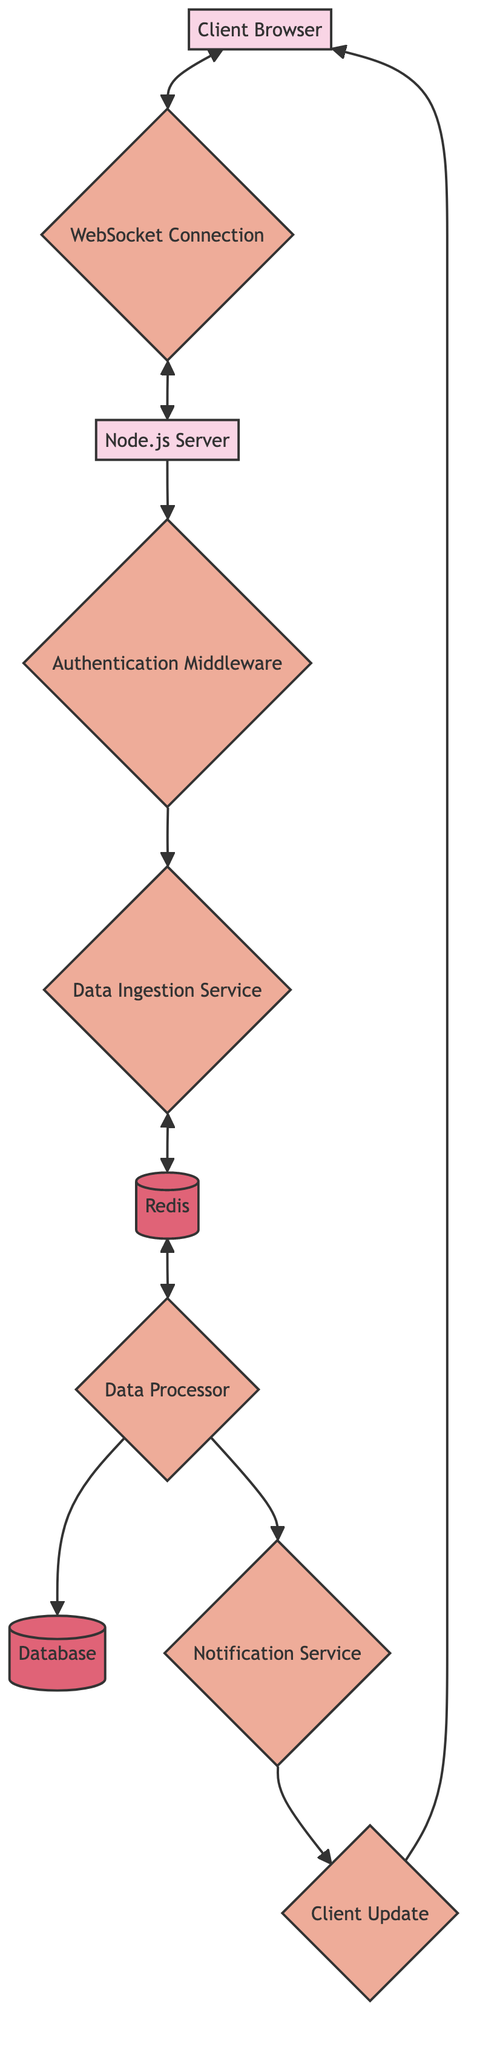What is the starting point of the workflow? The workflow starts with the "Client Browser" which initiates the data stream.
Answer: Client Browser How many entities are present in the workflow? There are three entities: Client Browser, Node.js Server, and Database.
Answer: Three What is the role of the "Authentication Middleware"? The "Authentication Middleware" ensures that the client is authorized to send and receive real-time data.
Answer: Authorization Which component is responsible for sending notifications to clients? The "Notification Service" is responsible for sending notifications or updates to clients after data processing.
Answer: Notification Service What type of connection is established between the Client Browser and the Node.js Server? A "WebSocket Connection" is established between the Client Browser and the Node.js Server.
Answer: WebSocket Connection What type of store is used as a message broker in the workflow? "Redis" is used as an in-memory data structure store for message brokering in the workflow.
Answer: Redis How does data flow from the Data Processor to the Database? The Data Processor processes data and then sends it directly to the Database for persistence.
Answer: Directly Which process follows the Data Ingestion Service? The "Data Processor" follows the Data Ingestion Service and applies business logic to the ingested data.
Answer: Data Processor What is the final step in the workflow after the data is processed? The final step is the "Client Update," which transmits real-time processed data or notifications back to the client browser.
Answer: Client Update 